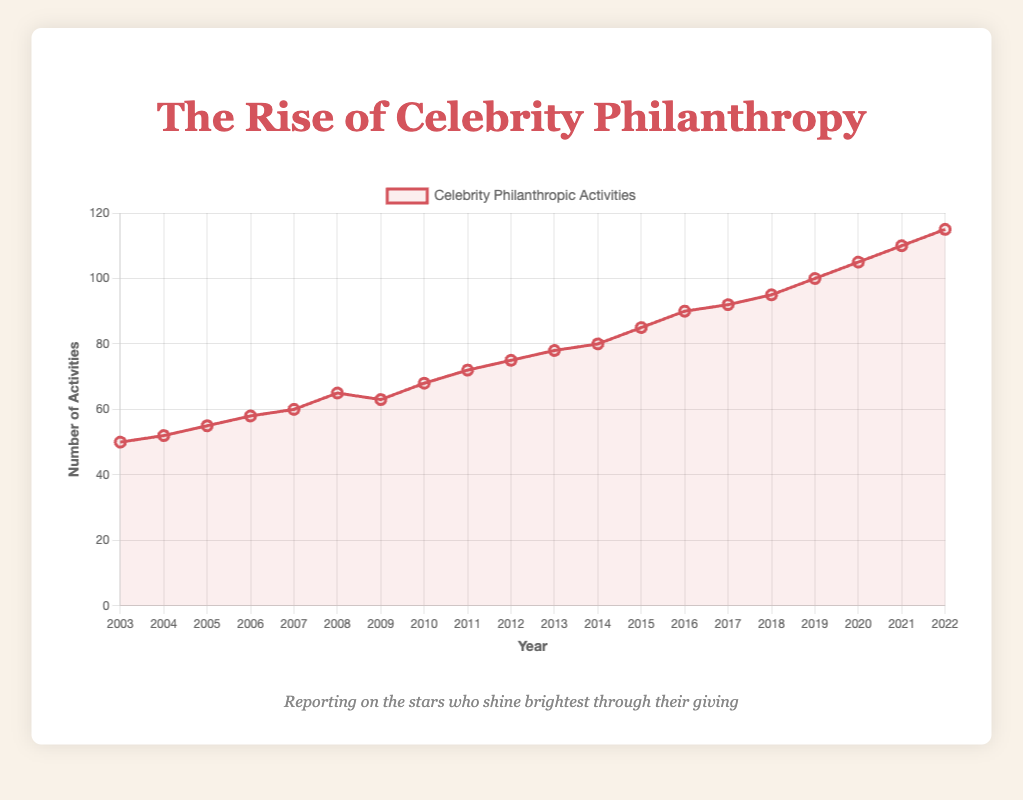What is the overall trend in celebrity philanthropic activities over the last 20 years? The figure shows a line plot representing the number of celebrity philanthropic activities from 2003 to 2022. By observing the line, we can see a steady upward trend, indicating that the frequency of these activities has increased over the years.
Answer: Increasing trend In which year did the number of celebrity philanthropic activities see the most significant drop from the previous year? By looking at the line plot, we can see the steepest decline happens between the years 2008 and 2009, where the number of activities dropped from 65 to 63.
Answer: 2009 How does the number of activities in 2012 compare to the number in 2022? We can compare the values in the figure for the years 2012 and 2022. In 2012, the number of activities is 75, and in 2022, it is 115. So, there is an increase.
Answer: Increased by 40 What is the average number of philanthropic activities from 2003 to 2012? The numbers for each year from 2003 to 2012 are: 50, 52, 55, 58, 60, 65, 63, 68, 72, and 75. To find the average: sum these numbers (50 + 52 + 55 + 58 + 60 + 65 + 63 + 68 + 72 + 75 = 618) and divide by 10 (number of years). So, the average is 618 / 10 = 61.8
Answer: 61.8 What is the rate of change in the number of activities between 2019 and 2020? To find the rate of change, we calculate the difference between the number in 2020 and 2019, then divide by the number in 2019. The values are 105 activities in 2020 and 100 in 2019. The difference is 105 - 100 = 5. The rate of change is 5 / 100 = 0.05 or 5%.
Answer: 5% Which years showed a consistent increase in the number of philanthropic activities without any decline year-on-year? From the figure, by observing the line plot segment by segment, we see that from 2010 to 2022, the number of activities increased consistently every year.
Answer: 2010 to 2022 What is the total increase in the number of activities from 2003 to 2022? The number of activities in 2003 is 50 and in 2022 is 115. To find the increase: 115 - 50 = 65.
Answer: 65 How many times did the number of activities stay the same or decrease compared to the previous year? By observing the figure for all the years: 2003 to 2004 (increase), 2004 to 2005 (increase), ... , the only year the activities decreased is 2009 compared to 2008. There is no instance where the number stayed the same.
Answer: 1 time 